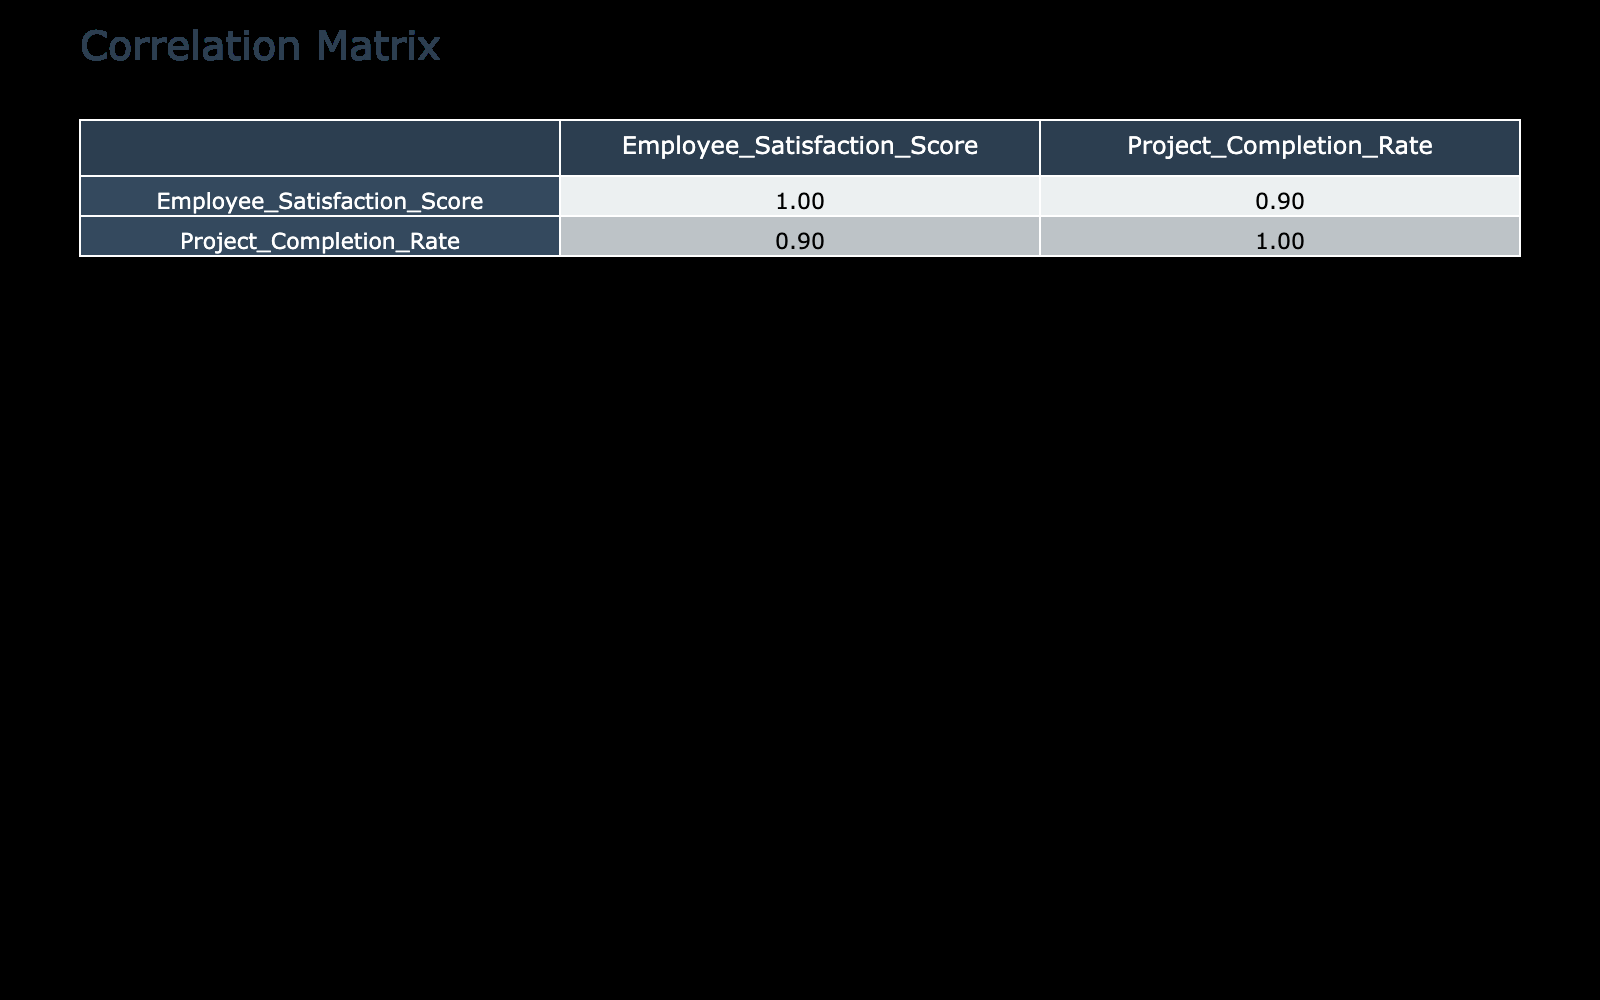What is the Employee Satisfaction Score for the Finance department? The Finance department's row indicates that the Employee Satisfaction Score is listed as 88.
Answer: 88 What is the Project Completion Rate for the Engineering department? Looking at the Engineering department's row in the table, the Project Completion Rate is shown as 90.
Answer: 90 Which department has the highest Employee Satisfaction Score? By comparing the Employee Satisfaction Scores across all departments, Finance has the highest score at 88.
Answer: Finance What is the average Employee Satisfaction Score for departments with a Project Completion Rate greater than 80? First, identify departments with Project Completion Rates above 80: Engineering (82), Finance (88), Product Development (80), Research and Development (85). The Scores are 82, 88, 80, and 85 which sum to 335. There are 4 departments, so the average is 335/4 = 83.75.
Answer: 83.75 Is the Project Completion Rate for Customer Service higher than that for IT? The Project Completion Rate for Customer Service is 65 and for IT is 70. Since 65 is not higher than 70, the answer is no.
Answer: No Which department shows the least satisfaction and what is the score? By checking the Employee Satisfaction Scores, Customer Service has the lowest score at 60.
Answer: Customer Service, 60 What is the difference between the maximum and minimum Project Completion Rates? The maximum Project Completion Rate is 95 (Finance), and the minimum is 65 (Customer Service). The difference is 95 - 65 = 30.
Answer: 30 If you list departments in descending order of their Project Completion Rates, which department would be third? Sorting the Project Completion Rates from highest to lowest gives: Finance (95), Engineering (90), Research and Development (92), Product Development (88), etc. The third entry is Research and Development.
Answer: Research and Development Is there a positive correlation between Employee Satisfaction Score and Project Completion Rate based on the given data? Positive correlation means that as one variable increases, the other should also increase. Observing the scores and rates, Finance, Engineering, and others generally show higher satisfaction corresponding to higher completion rates. Therefore, there is a positive correlation.
Answer: Yes 